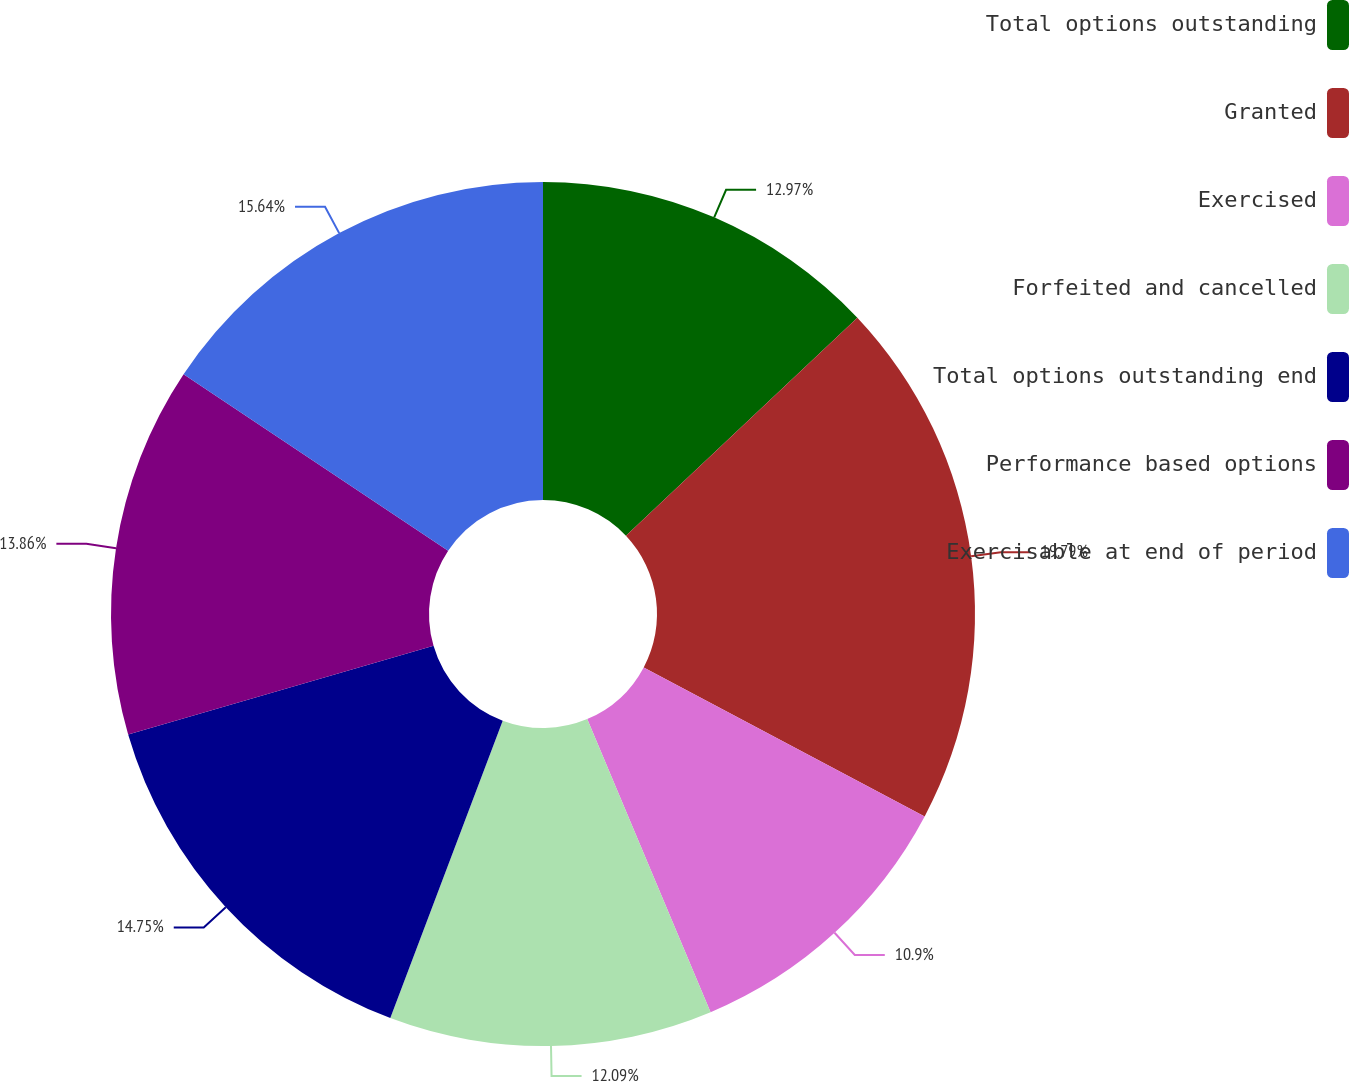Convert chart to OTSL. <chart><loc_0><loc_0><loc_500><loc_500><pie_chart><fcel>Total options outstanding<fcel>Granted<fcel>Exercised<fcel>Forfeited and cancelled<fcel>Total options outstanding end<fcel>Performance based options<fcel>Exercisable at end of period<nl><fcel>12.97%<fcel>19.79%<fcel>10.9%<fcel>12.09%<fcel>14.75%<fcel>13.86%<fcel>15.64%<nl></chart> 